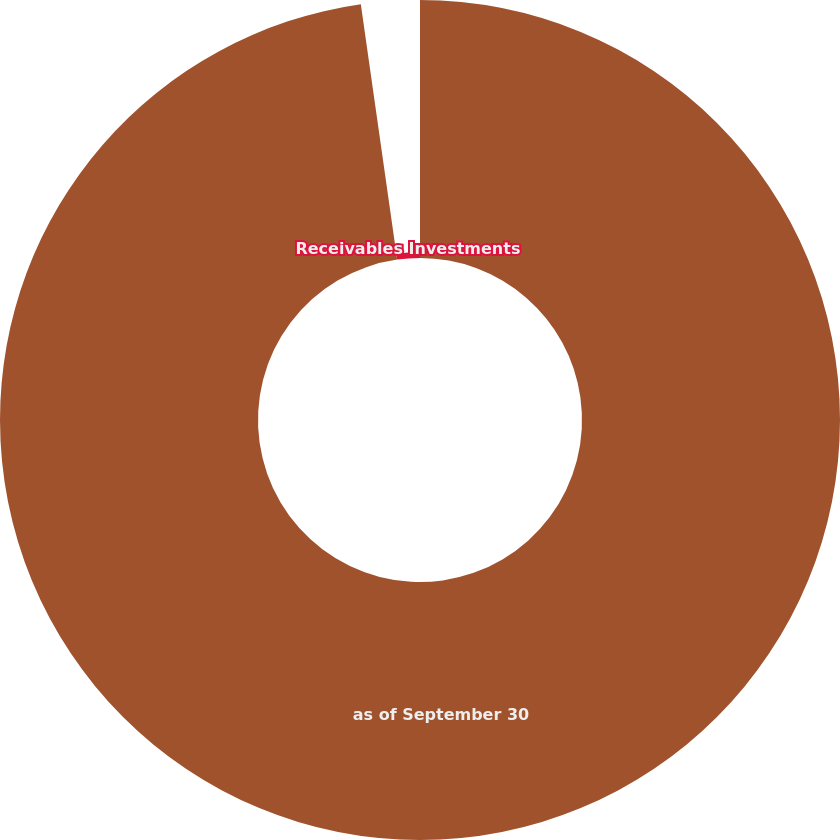Convert chart to OTSL. <chart><loc_0><loc_0><loc_500><loc_500><pie_chart><fcel>as of September 30<fcel>Receivables Investments<nl><fcel>97.75%<fcel>2.25%<nl></chart> 